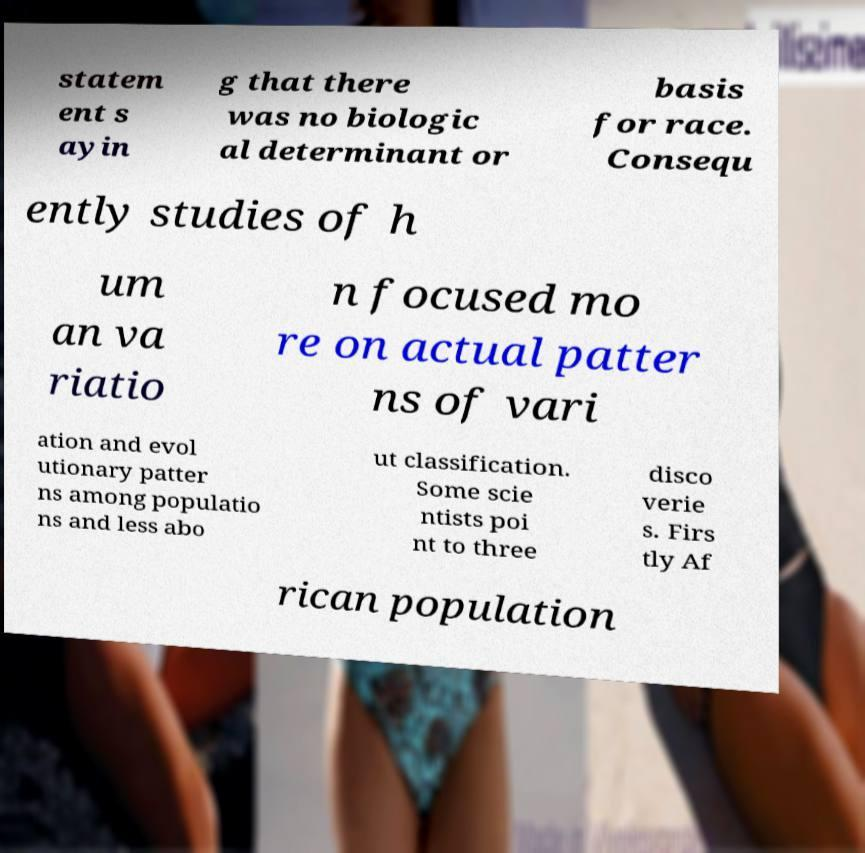What messages or text are displayed in this image? I need them in a readable, typed format. statem ent s ayin g that there was no biologic al determinant or basis for race. Consequ ently studies of h um an va riatio n focused mo re on actual patter ns of vari ation and evol utionary patter ns among populatio ns and less abo ut classification. Some scie ntists poi nt to three disco verie s. Firs tly Af rican population 